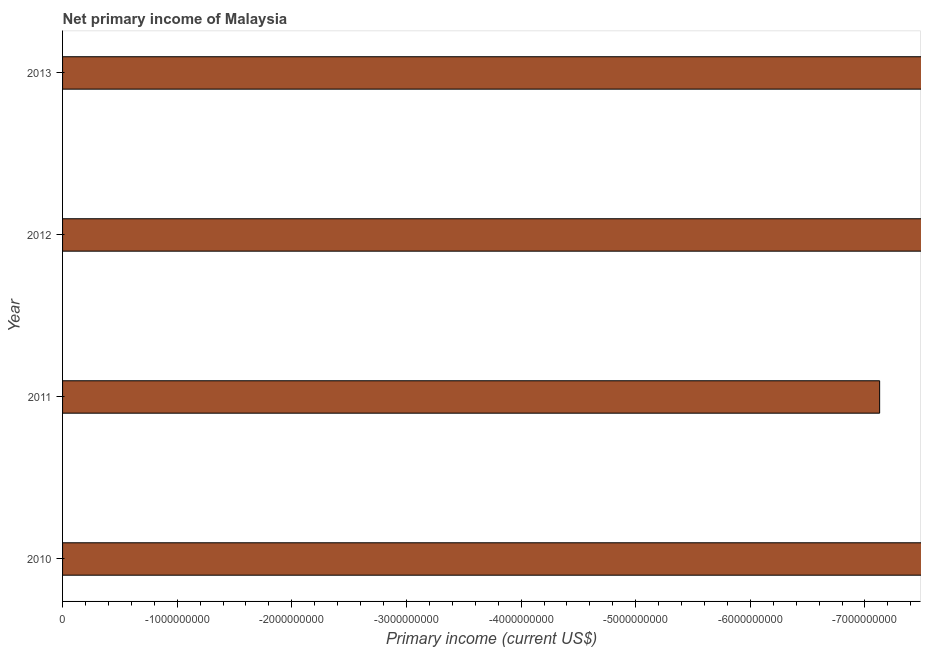Does the graph contain any zero values?
Your answer should be very brief. Yes. What is the title of the graph?
Provide a short and direct response. Net primary income of Malaysia. What is the label or title of the X-axis?
Give a very brief answer. Primary income (current US$). What is the label or title of the Y-axis?
Offer a very short reply. Year. What is the amount of primary income in 2011?
Provide a succinct answer. 0. What is the median amount of primary income?
Your answer should be very brief. 0. In how many years, is the amount of primary income greater than the average amount of primary income taken over all years?
Offer a terse response. 0. What is the difference between two consecutive major ticks on the X-axis?
Offer a terse response. 1.00e+09. What is the Primary income (current US$) in 2010?
Your response must be concise. 0. What is the Primary income (current US$) in 2013?
Give a very brief answer. 0. 